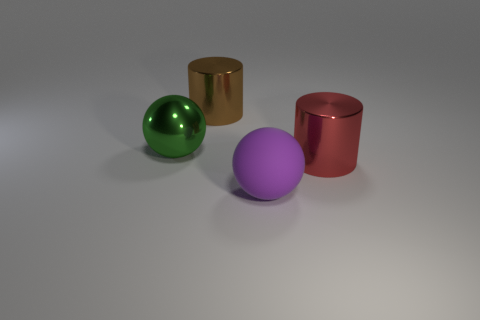Add 1 green shiny things. How many objects exist? 5 Subtract 1 brown cylinders. How many objects are left? 3 Subtract all red cylinders. Subtract all rubber objects. How many objects are left? 2 Add 1 purple rubber objects. How many purple rubber objects are left? 2 Add 2 shiny cylinders. How many shiny cylinders exist? 4 